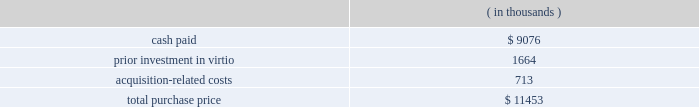Fair value of the tangible assets and identifiable intangible assets acquired , was $ 17.7 million .
Goodwill resulted primarily from the company 2019s expectation of synergies from the integration of sigma-c 2019s technology with the company 2019s technology and operations .
Virtio corporation , inc .
( virtio ) the company acquired virtio on may 15 , 2006 in an all-cash transaction .
Reasons for the acquisition .
The company believes that its acquisition of virtio will expand its presence in electronic system level design .
The company expects the combination of the company 2019s system studio solution with virtio 2019s virtual prototyping technology will help accelerate systems to market by giving software developers the ability to begin code development earlier than with prevailing methods .
Purchase price .
The company paid $ 9.1 million in cash for the outstanding shares of virtio , of which $ 0.9 million was deposited with an escrow agent and which will be paid to the former stockholders of virtio pursuant to the terms of an escrow agreement .
In addition , the company had a prior investment in virtio of approximately $ 1.7 million .
The total purchase consideration consisted of: .
Acquisition-related costs of $ 0.7 million consist primarily of legal , tax and accounting fees , estimated facilities closure costs and employee termination costs .
As of october 31 , 2006 , the company had paid $ 0.3 million of the acquisition-related costs .
The $ 0.4 million balance remaining at october 31 , 2006 primarily consists of professional and tax-related service fees and facilities closure costs .
Under the agreement with virtio , the company has also agreed to pay up to $ 4.3 million over three years to the former stockholders based upon achievement of certain sales milestones .
This contingent consideration is considered to be additional purchase price and will be an adjustment to goodwill when and if payment is made .
Additionally , the company has also agreed to pay $ 0.9 million in employee retention bonuses which will be recognized as compensation expense over the service period of the applicable employees .
Assets acquired .
The company has performed a preliminary valuation and allocated the total purchase consideration to the assets and liabilities acquired , including identifiable intangible assets based on their respective fair values on the acquisition date .
The company acquired $ 2.5 million of intangible assets consisting of $ 1.9 million in existing technology , $ 0.4 million in customer relationships and $ 0.2 million in non-compete agreements to be amortized over five to seven years .
Additionally , the company acquired tangible assets of $ 5.5 million and assumed liabilities of $ 3.2 million .
Goodwill , representing the excess of the purchase price over the fair value of the net tangible and identifiable intangible assets acquired in the merger , was $ 6.7 million .
Goodwill resulted primarily from the company 2019s expectation of synergies from the integration of virtio 2019s technology with the company 2019s technology and operations .
Hpl technologies , inc .
( hpl ) the company acquired hpl on december 7 , 2005 in an all-cash transaction .
Reasons for the acquisition .
The company believes that the acquisition of hpl will help solidify the company 2019s position as a leading electronic design automation vendor in design for manufacturing ( dfm ) .
What is the percentage of customer relationships among the total intangible assets? 
Rationale: it is the value of the customer relationships divided by the total value of intangible assets , then turned into a percentage .
Computations: (0.4 / 2.5)
Answer: 0.16. 